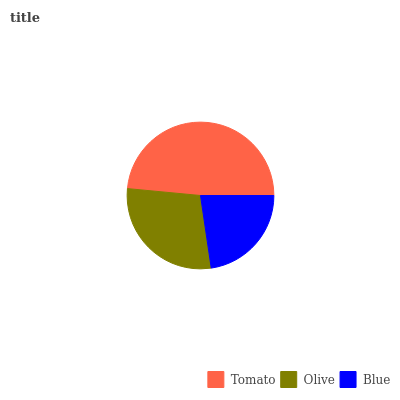Is Blue the minimum?
Answer yes or no. Yes. Is Tomato the maximum?
Answer yes or no. Yes. Is Olive the minimum?
Answer yes or no. No. Is Olive the maximum?
Answer yes or no. No. Is Tomato greater than Olive?
Answer yes or no. Yes. Is Olive less than Tomato?
Answer yes or no. Yes. Is Olive greater than Tomato?
Answer yes or no. No. Is Tomato less than Olive?
Answer yes or no. No. Is Olive the high median?
Answer yes or no. Yes. Is Olive the low median?
Answer yes or no. Yes. Is Tomato the high median?
Answer yes or no. No. Is Blue the low median?
Answer yes or no. No. 